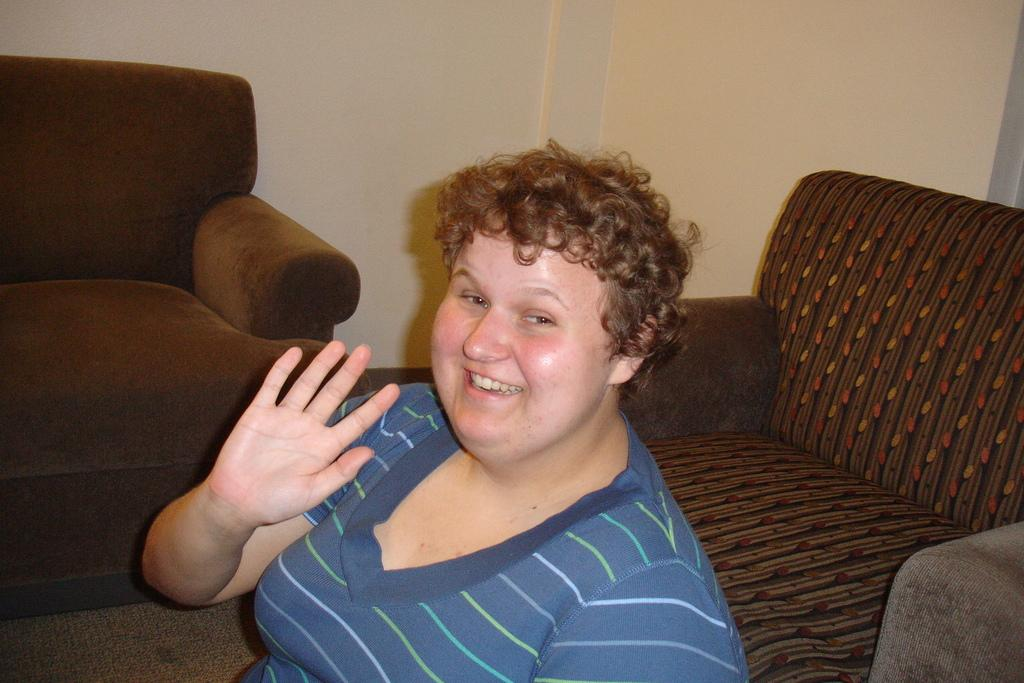What is the person in the image doing? The person is sitting on the floor in the image. What is the person's facial expression? The person is smiling. What type of furniture can be seen in the image? There are sofas in the image. What is the background of the image? There is a wall in the image. What type of parcel is being delivered to the person in the image? There is no parcel present in the image. Can you see a kite flying in the background of the image? There is no kite visible in the image; it only features a person sitting on the floor, sofas, and a wall. 